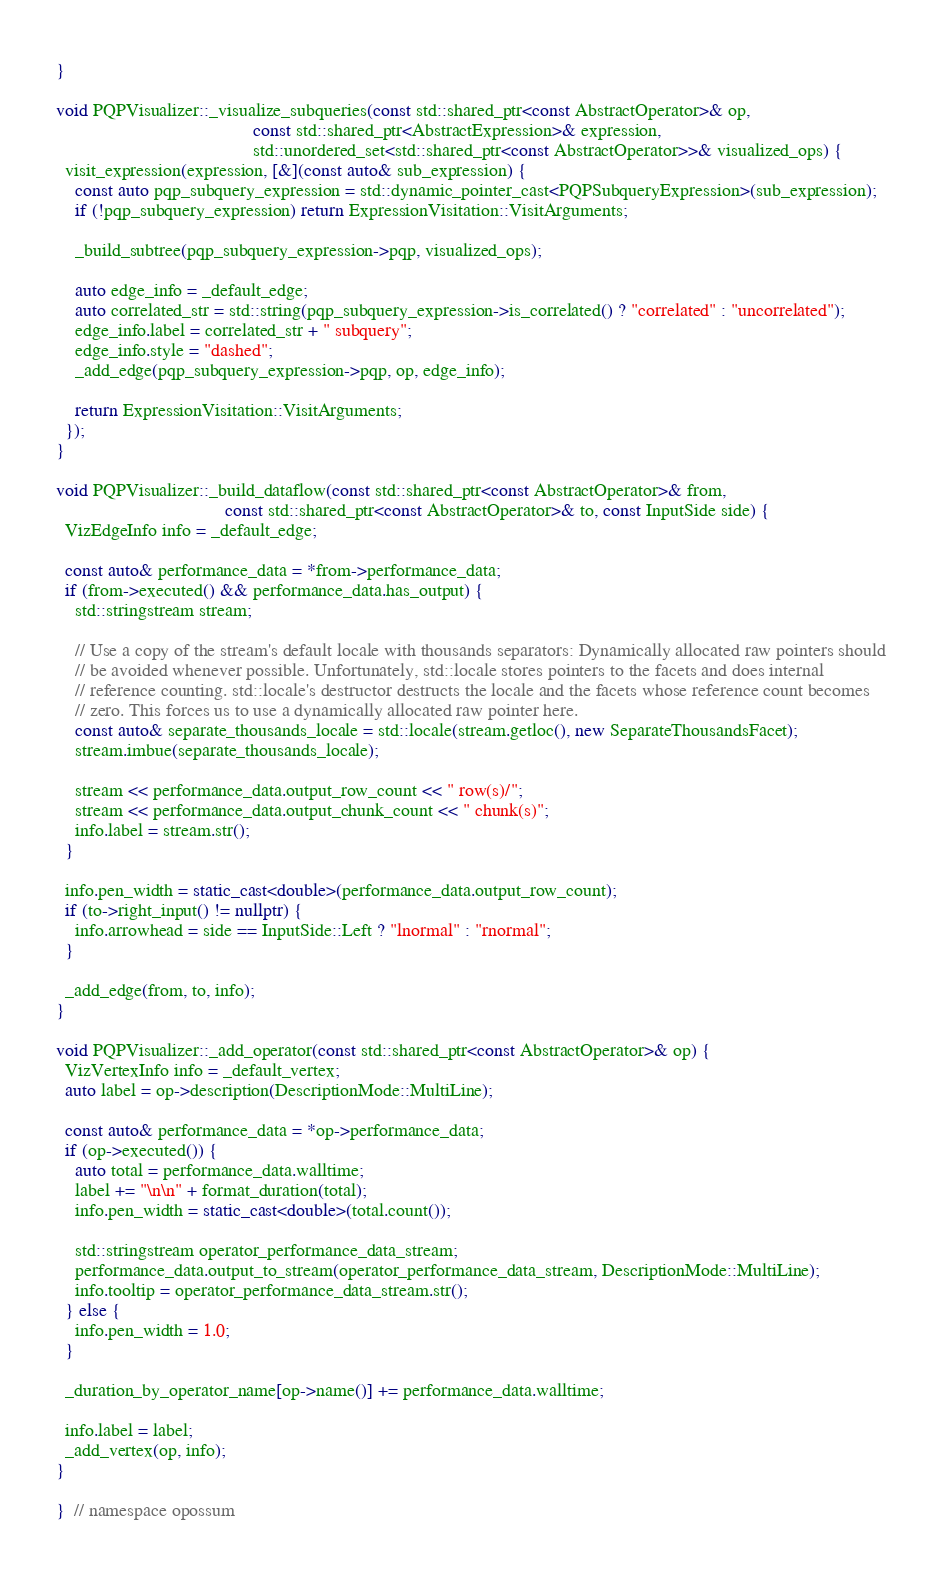<code> <loc_0><loc_0><loc_500><loc_500><_C++_>}

void PQPVisualizer::_visualize_subqueries(const std::shared_ptr<const AbstractOperator>& op,
                                          const std::shared_ptr<AbstractExpression>& expression,
                                          std::unordered_set<std::shared_ptr<const AbstractOperator>>& visualized_ops) {
  visit_expression(expression, [&](const auto& sub_expression) {
    const auto pqp_subquery_expression = std::dynamic_pointer_cast<PQPSubqueryExpression>(sub_expression);
    if (!pqp_subquery_expression) return ExpressionVisitation::VisitArguments;

    _build_subtree(pqp_subquery_expression->pqp, visualized_ops);

    auto edge_info = _default_edge;
    auto correlated_str = std::string(pqp_subquery_expression->is_correlated() ? "correlated" : "uncorrelated");
    edge_info.label = correlated_str + " subquery";
    edge_info.style = "dashed";
    _add_edge(pqp_subquery_expression->pqp, op, edge_info);

    return ExpressionVisitation::VisitArguments;
  });
}

void PQPVisualizer::_build_dataflow(const std::shared_ptr<const AbstractOperator>& from,
                                    const std::shared_ptr<const AbstractOperator>& to, const InputSide side) {
  VizEdgeInfo info = _default_edge;

  const auto& performance_data = *from->performance_data;
  if (from->executed() && performance_data.has_output) {
    std::stringstream stream;

    // Use a copy of the stream's default locale with thousands separators: Dynamically allocated raw pointers should
    // be avoided whenever possible. Unfortunately, std::locale stores pointers to the facets and does internal
    // reference counting. std::locale's destructor destructs the locale and the facets whose reference count becomes
    // zero. This forces us to use a dynamically allocated raw pointer here.
    const auto& separate_thousands_locale = std::locale(stream.getloc(), new SeparateThousandsFacet);
    stream.imbue(separate_thousands_locale);

    stream << performance_data.output_row_count << " row(s)/";
    stream << performance_data.output_chunk_count << " chunk(s)";
    info.label = stream.str();
  }

  info.pen_width = static_cast<double>(performance_data.output_row_count);
  if (to->right_input() != nullptr) {
    info.arrowhead = side == InputSide::Left ? "lnormal" : "rnormal";
  }

  _add_edge(from, to, info);
}

void PQPVisualizer::_add_operator(const std::shared_ptr<const AbstractOperator>& op) {
  VizVertexInfo info = _default_vertex;
  auto label = op->description(DescriptionMode::MultiLine);

  const auto& performance_data = *op->performance_data;
  if (op->executed()) {
    auto total = performance_data.walltime;
    label += "\n\n" + format_duration(total);
    info.pen_width = static_cast<double>(total.count());

    std::stringstream operator_performance_data_stream;
    performance_data.output_to_stream(operator_performance_data_stream, DescriptionMode::MultiLine);
    info.tooltip = operator_performance_data_stream.str();
  } else {
    info.pen_width = 1.0;
  }

  _duration_by_operator_name[op->name()] += performance_data.walltime;

  info.label = label;
  _add_vertex(op, info);
}

}  // namespace opossum
</code> 